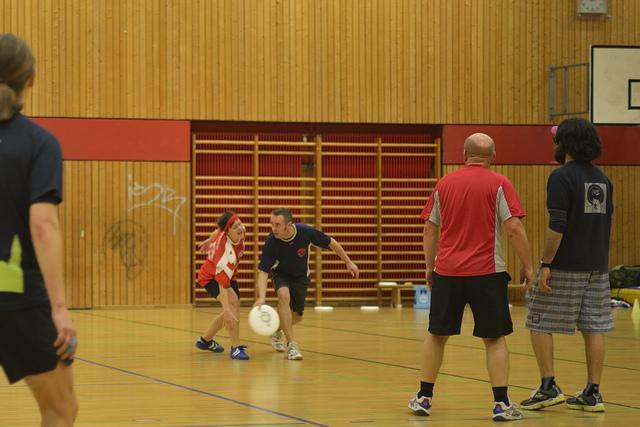How many men are there?
Give a very brief answer. 3. How many people are there?
Give a very brief answer. 5. 